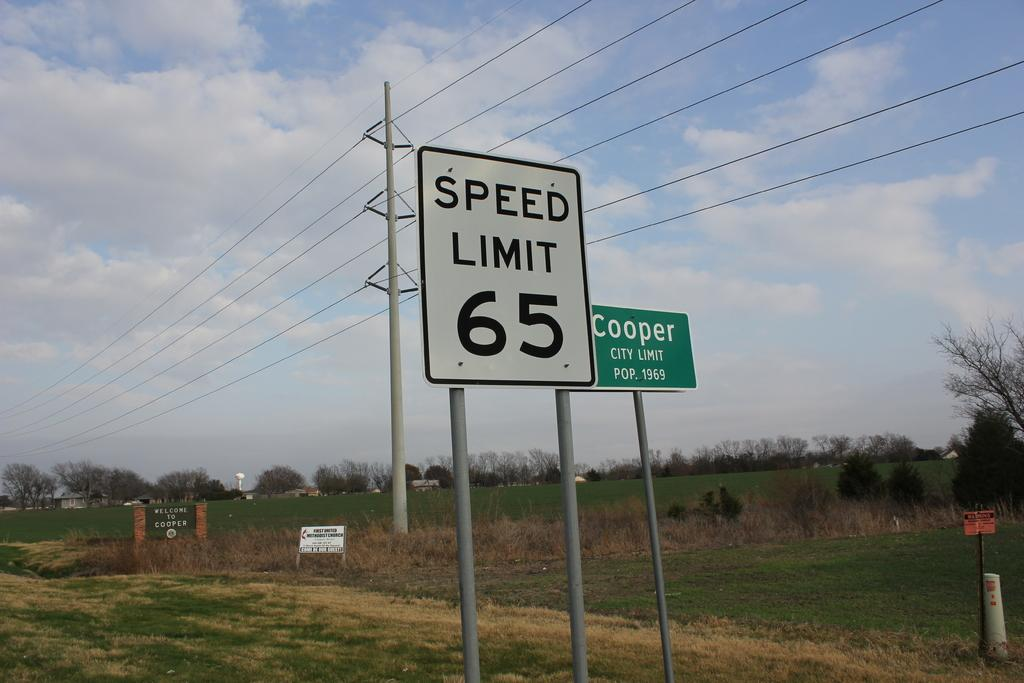Provide a one-sentence caption for the provided image. A city limit sign saying "Cooper, city limit pop 1969 and a “speed limit 65” sign are in the foreground against a rural setting. 